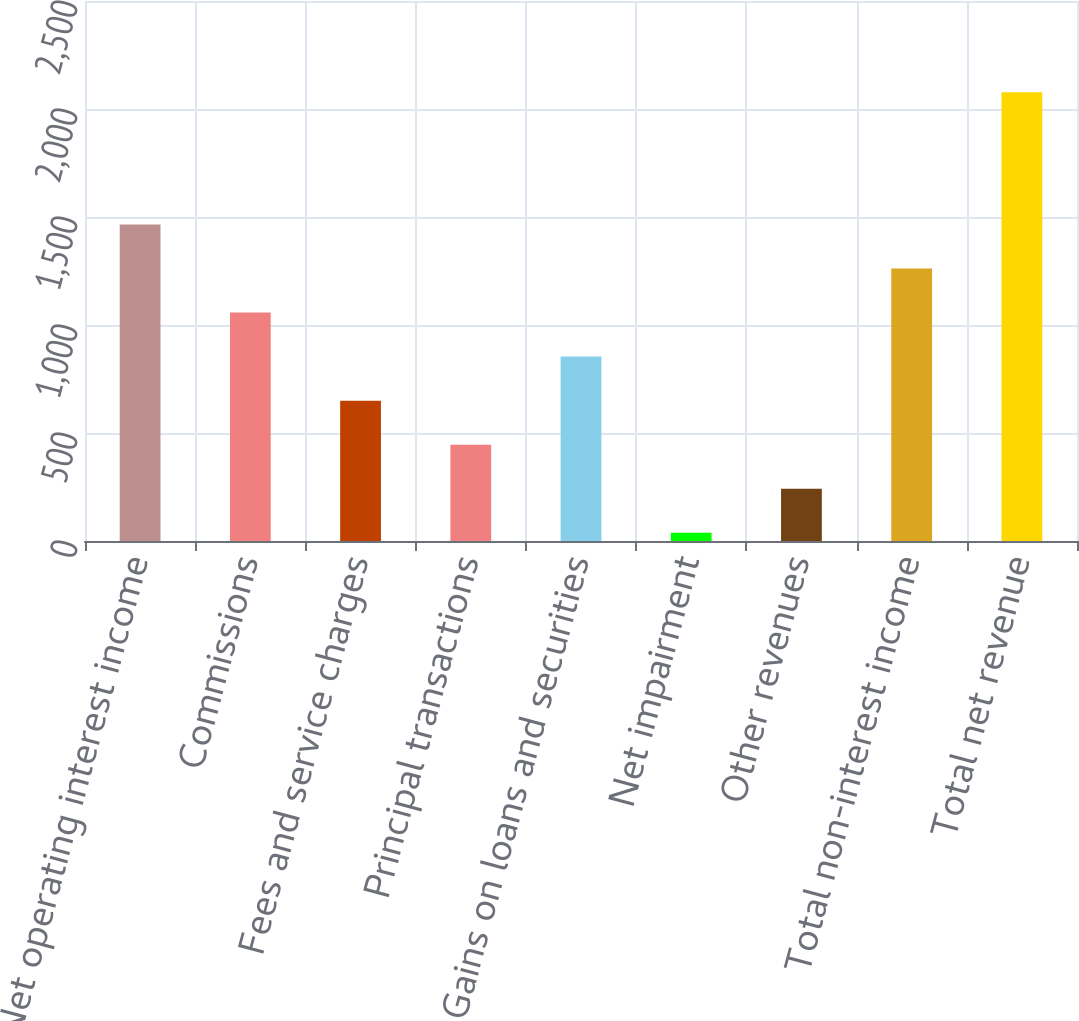Convert chart. <chart><loc_0><loc_0><loc_500><loc_500><bar_chart><fcel>Net operating interest income<fcel>Commissions<fcel>Fees and service charges<fcel>Principal transactions<fcel>Gains on loans and securities<fcel>Net impairment<fcel>Other revenues<fcel>Total non-interest income<fcel>Total net revenue<nl><fcel>1465.84<fcel>1057.8<fcel>649.76<fcel>445.74<fcel>853.78<fcel>37.7<fcel>241.72<fcel>1261.82<fcel>2077.9<nl></chart> 